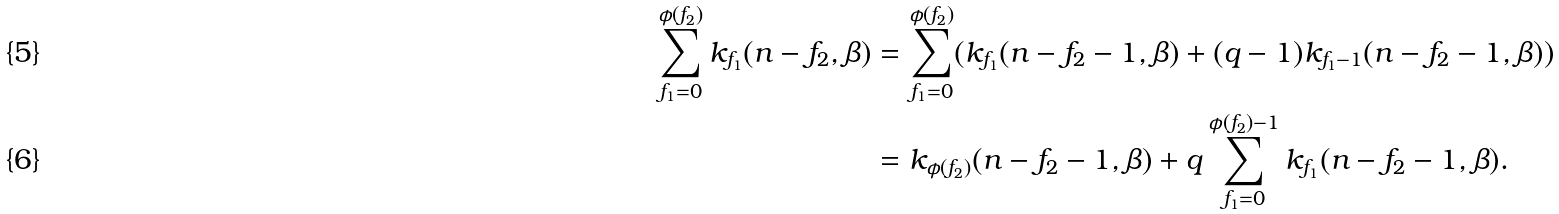<formula> <loc_0><loc_0><loc_500><loc_500>\sum _ { f _ { 1 } = 0 } ^ { \phi ( f _ { 2 } ) } k _ { f _ { 1 } } ( n - f _ { 2 } , \beta ) & = \sum _ { f _ { 1 } = 0 } ^ { \phi ( f _ { 2 } ) } ( k _ { f _ { 1 } } ( n - f _ { 2 } - 1 , \beta ) + ( q - 1 ) k _ { f _ { 1 } - 1 } ( n - f _ { 2 } - 1 , \beta ) ) \\ & = k _ { \phi ( f _ { 2 } ) } ( n - f _ { 2 } - 1 , \beta ) + q \sum _ { f _ { 1 } = 0 } ^ { \phi ( f _ { 2 } ) - 1 } k _ { f _ { 1 } } ( n - f _ { 2 } - 1 , \beta ) .</formula> 